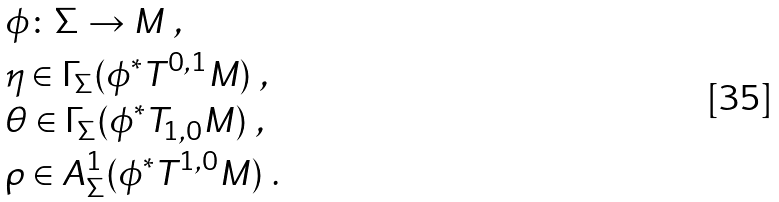Convert formula to latex. <formula><loc_0><loc_0><loc_500><loc_500>& \phi \colon \Sigma \to M \ , \\ & \eta \in \Gamma _ { \Sigma } ( \phi ^ { * } T ^ { 0 , 1 } M ) \ , \\ & \theta \in \Gamma _ { \Sigma } ( \phi ^ { * } T _ { 1 , 0 } M ) \ , \\ & \rho \in A ^ { 1 } _ { \Sigma } ( \phi ^ { * } T ^ { 1 , 0 } M ) \ .</formula> 